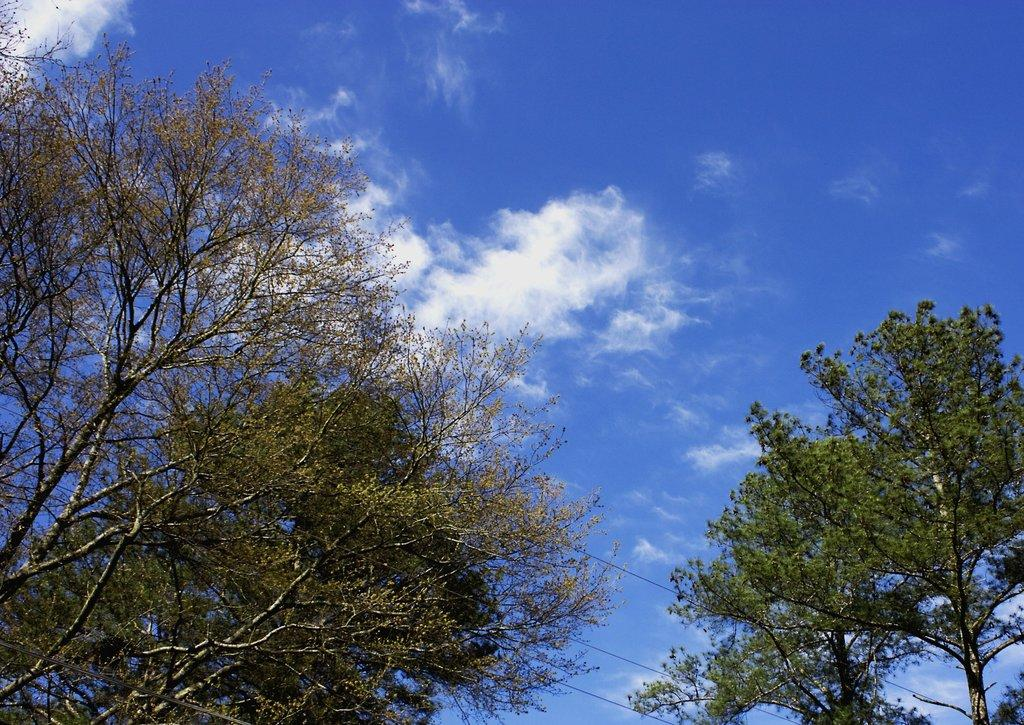What type of vegetation can be seen in the image? There are trees in the image. What color are the trees in the image? The trees are green in color. What else is visible in the image besides the trees? The sky is visible in the image. What colors can be seen in the sky in the image? The sky is blue and white in color. What type of company is responsible for the acoustics in the image? There is no company or acoustics mentioned in the image; it features trees and a blue and white sky. What type of wood is used to construct the trees in the image? The image does not provide information about the type of wood used to construct the trees, as it only shows the trees' green color and the blue and white sky. 